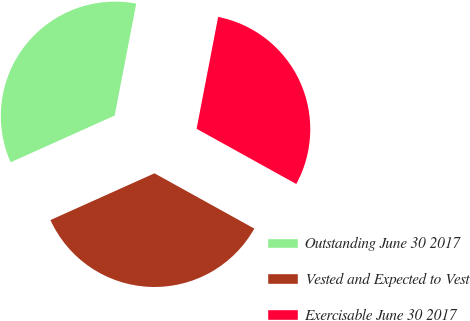Convert chart to OTSL. <chart><loc_0><loc_0><loc_500><loc_500><pie_chart><fcel>Outstanding June 30 2017<fcel>Vested and Expected to Vest<fcel>Exercisable June 30 2017<nl><fcel>34.75%<fcel>35.23%<fcel>30.02%<nl></chart> 